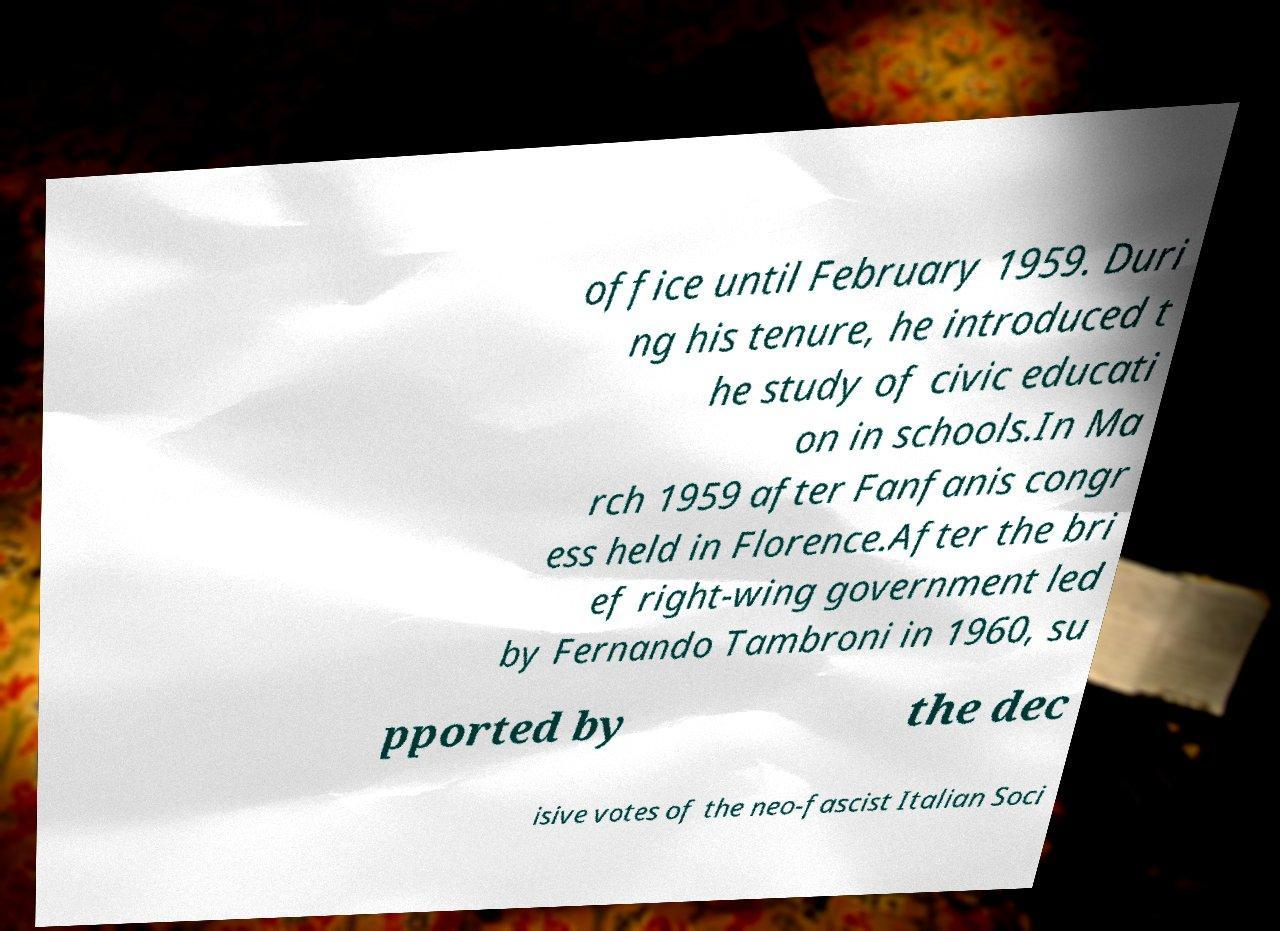Could you extract and type out the text from this image? office until February 1959. Duri ng his tenure, he introduced t he study of civic educati on in schools.In Ma rch 1959 after Fanfanis congr ess held in Florence.After the bri ef right-wing government led by Fernando Tambroni in 1960, su pported by the dec isive votes of the neo-fascist Italian Soci 